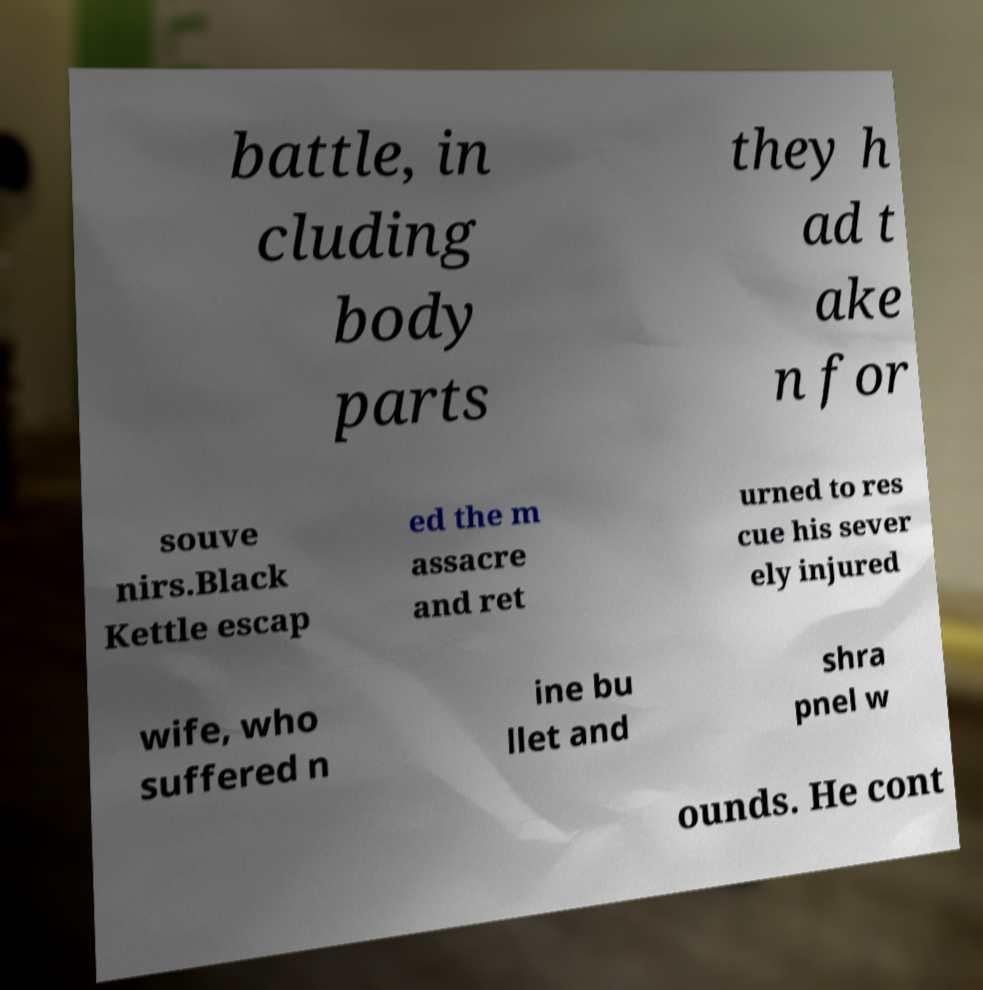Can you accurately transcribe the text from the provided image for me? battle, in cluding body parts they h ad t ake n for souve nirs.Black Kettle escap ed the m assacre and ret urned to res cue his sever ely injured wife, who suffered n ine bu llet and shra pnel w ounds. He cont 